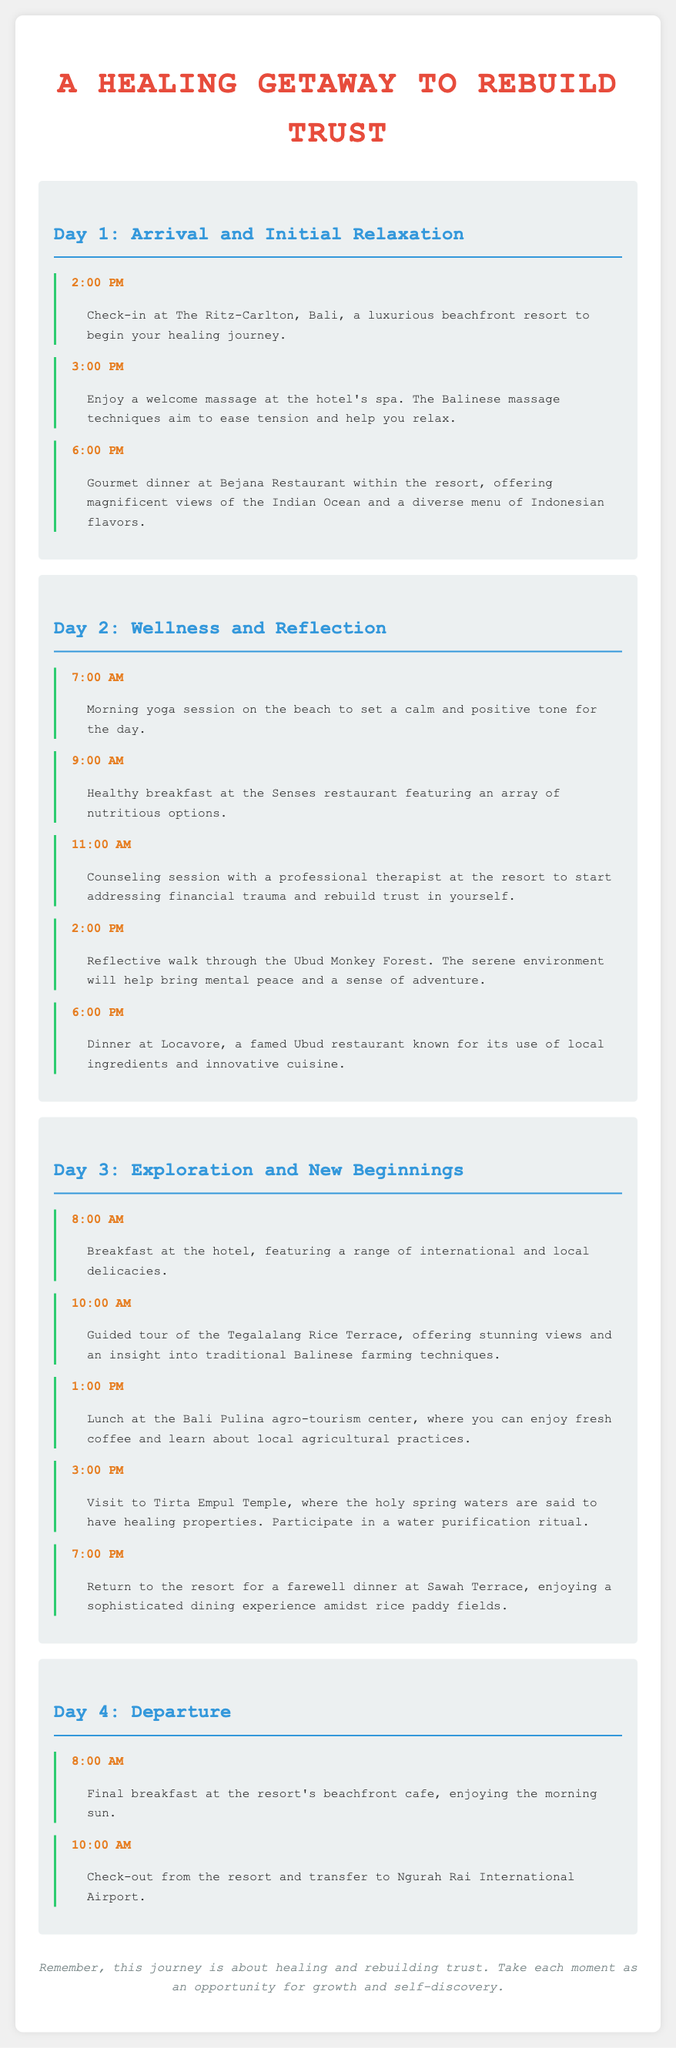what time is check-in at The Ritz-Carlton, Bali? Check-in time is mentioned as 2:00 PM in the itinerary for Day 1.
Answer: 2:00 PM what type of massage is offered on Day 1? The itinerary specifies that a welcome massage at the hotel's spa uses Balinese massage techniques.
Answer: Balinese massage where is the dinner on Day 1 served? The dinner is served at Bejana Restaurant within the resort.
Answer: Bejana Restaurant how many activities are scheduled for Day 2? Day 2 lists five activities including yoga and a counseling session.
Answer: Five activities what is the purpose of the counseling session on Day 2? The session aims to address financial trauma and rebuild trust in oneself.
Answer: Rebuild trust which restaurant is known for using local ingredients on Day 2? The restaurant mentioned is Locavore, noted for its innovative cuisine.
Answer: Locavore what is scheduled to happen at 10:00 AM on Day 4? The itinerary indicates check-out from the resort and transfer to the airport at this time.
Answer: Check-out what is the theme of the getaway mentioned in the itinerary? The getaway focuses on healing and rebuilding trust.
Answer: Healing and rebuilding trust 